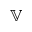<formula> <loc_0><loc_0><loc_500><loc_500>\mathbb { V }</formula> 